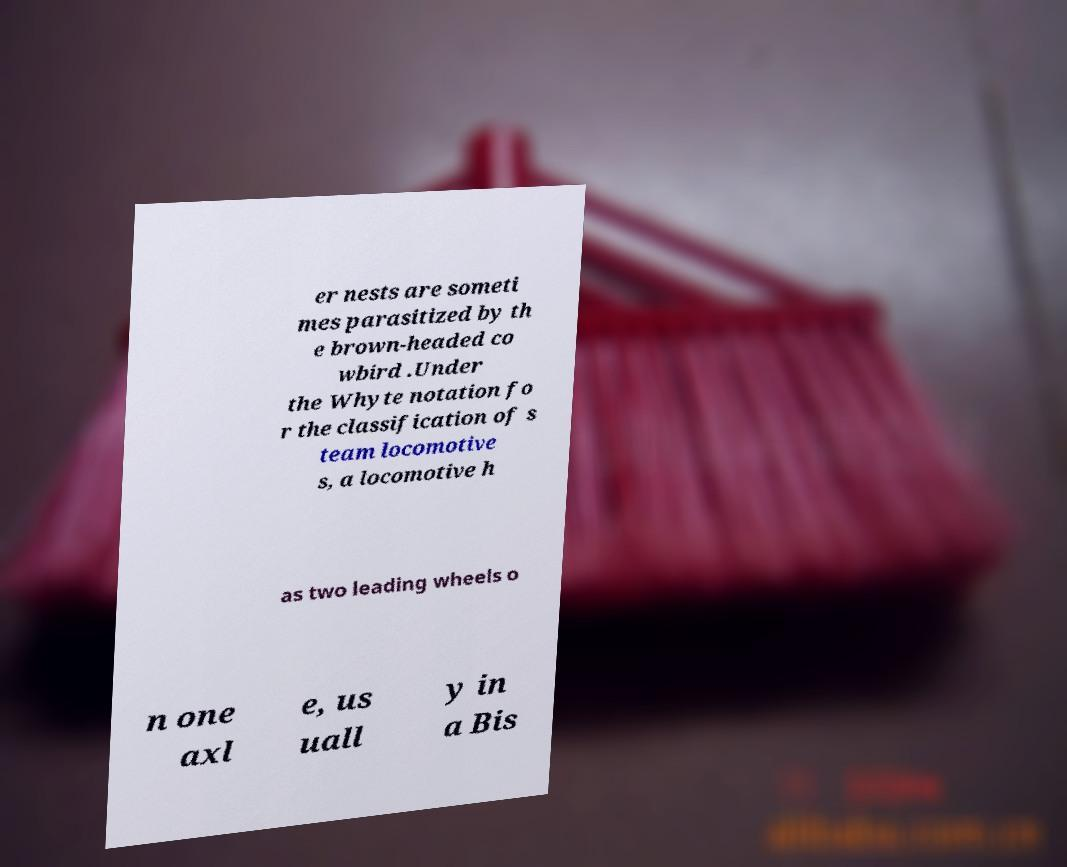There's text embedded in this image that I need extracted. Can you transcribe it verbatim? er nests are someti mes parasitized by th e brown-headed co wbird .Under the Whyte notation fo r the classification of s team locomotive s, a locomotive h as two leading wheels o n one axl e, us uall y in a Bis 